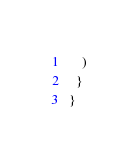Convert code to text. <code><loc_0><loc_0><loc_500><loc_500><_JavaScript_>    )
  }
}
</code> 